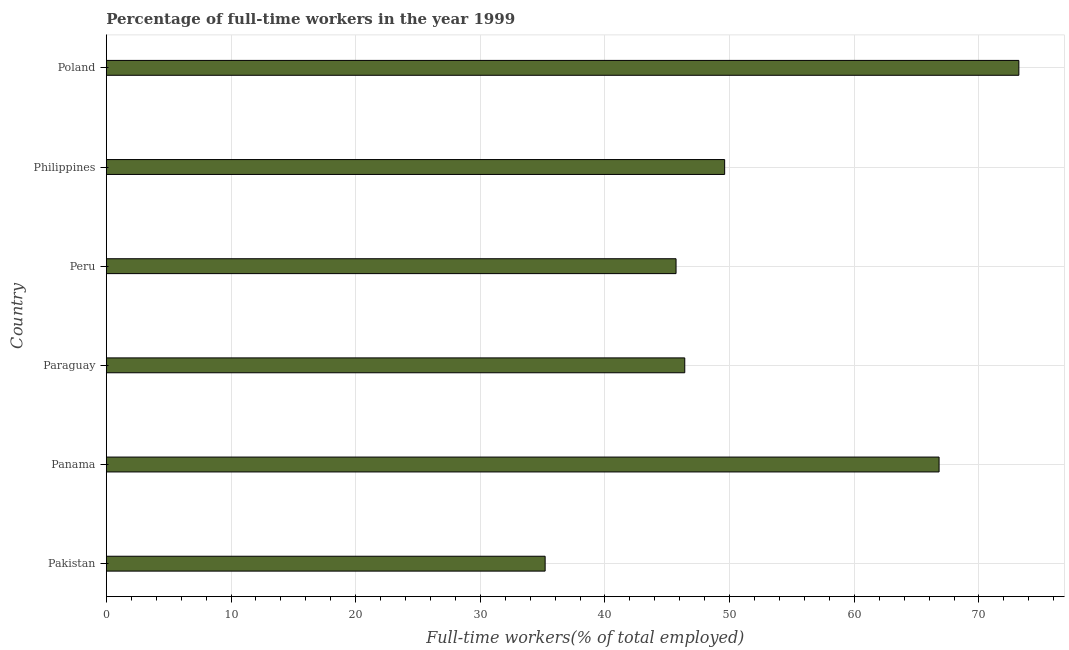Does the graph contain any zero values?
Offer a very short reply. No. Does the graph contain grids?
Give a very brief answer. Yes. What is the title of the graph?
Give a very brief answer. Percentage of full-time workers in the year 1999. What is the label or title of the X-axis?
Offer a terse response. Full-time workers(% of total employed). What is the label or title of the Y-axis?
Make the answer very short. Country. What is the percentage of full-time workers in Paraguay?
Make the answer very short. 46.4. Across all countries, what is the maximum percentage of full-time workers?
Your answer should be very brief. 73.2. Across all countries, what is the minimum percentage of full-time workers?
Your answer should be compact. 35.2. In which country was the percentage of full-time workers maximum?
Make the answer very short. Poland. What is the sum of the percentage of full-time workers?
Offer a very short reply. 316.9. What is the difference between the percentage of full-time workers in Panama and Poland?
Ensure brevity in your answer.  -6.4. What is the average percentage of full-time workers per country?
Offer a terse response. 52.82. What is the ratio of the percentage of full-time workers in Pakistan to that in Philippines?
Offer a very short reply. 0.71. What is the difference between the highest and the second highest percentage of full-time workers?
Provide a succinct answer. 6.4. Is the sum of the percentage of full-time workers in Pakistan and Poland greater than the maximum percentage of full-time workers across all countries?
Your response must be concise. Yes. Are all the bars in the graph horizontal?
Your answer should be compact. Yes. How many countries are there in the graph?
Your answer should be compact. 6. What is the Full-time workers(% of total employed) in Pakistan?
Provide a succinct answer. 35.2. What is the Full-time workers(% of total employed) in Panama?
Make the answer very short. 66.8. What is the Full-time workers(% of total employed) in Paraguay?
Offer a very short reply. 46.4. What is the Full-time workers(% of total employed) of Peru?
Keep it short and to the point. 45.7. What is the Full-time workers(% of total employed) of Philippines?
Keep it short and to the point. 49.6. What is the Full-time workers(% of total employed) in Poland?
Provide a succinct answer. 73.2. What is the difference between the Full-time workers(% of total employed) in Pakistan and Panama?
Keep it short and to the point. -31.6. What is the difference between the Full-time workers(% of total employed) in Pakistan and Paraguay?
Offer a terse response. -11.2. What is the difference between the Full-time workers(% of total employed) in Pakistan and Peru?
Give a very brief answer. -10.5. What is the difference between the Full-time workers(% of total employed) in Pakistan and Philippines?
Your answer should be very brief. -14.4. What is the difference between the Full-time workers(% of total employed) in Pakistan and Poland?
Make the answer very short. -38. What is the difference between the Full-time workers(% of total employed) in Panama and Paraguay?
Offer a very short reply. 20.4. What is the difference between the Full-time workers(% of total employed) in Panama and Peru?
Keep it short and to the point. 21.1. What is the difference between the Full-time workers(% of total employed) in Panama and Poland?
Your answer should be very brief. -6.4. What is the difference between the Full-time workers(% of total employed) in Paraguay and Poland?
Make the answer very short. -26.8. What is the difference between the Full-time workers(% of total employed) in Peru and Philippines?
Provide a short and direct response. -3.9. What is the difference between the Full-time workers(% of total employed) in Peru and Poland?
Your answer should be compact. -27.5. What is the difference between the Full-time workers(% of total employed) in Philippines and Poland?
Ensure brevity in your answer.  -23.6. What is the ratio of the Full-time workers(% of total employed) in Pakistan to that in Panama?
Your answer should be compact. 0.53. What is the ratio of the Full-time workers(% of total employed) in Pakistan to that in Paraguay?
Your answer should be compact. 0.76. What is the ratio of the Full-time workers(% of total employed) in Pakistan to that in Peru?
Your answer should be very brief. 0.77. What is the ratio of the Full-time workers(% of total employed) in Pakistan to that in Philippines?
Offer a terse response. 0.71. What is the ratio of the Full-time workers(% of total employed) in Pakistan to that in Poland?
Make the answer very short. 0.48. What is the ratio of the Full-time workers(% of total employed) in Panama to that in Paraguay?
Ensure brevity in your answer.  1.44. What is the ratio of the Full-time workers(% of total employed) in Panama to that in Peru?
Your response must be concise. 1.46. What is the ratio of the Full-time workers(% of total employed) in Panama to that in Philippines?
Your answer should be compact. 1.35. What is the ratio of the Full-time workers(% of total employed) in Panama to that in Poland?
Offer a terse response. 0.91. What is the ratio of the Full-time workers(% of total employed) in Paraguay to that in Philippines?
Your answer should be very brief. 0.94. What is the ratio of the Full-time workers(% of total employed) in Paraguay to that in Poland?
Your answer should be compact. 0.63. What is the ratio of the Full-time workers(% of total employed) in Peru to that in Philippines?
Your answer should be very brief. 0.92. What is the ratio of the Full-time workers(% of total employed) in Peru to that in Poland?
Give a very brief answer. 0.62. What is the ratio of the Full-time workers(% of total employed) in Philippines to that in Poland?
Keep it short and to the point. 0.68. 